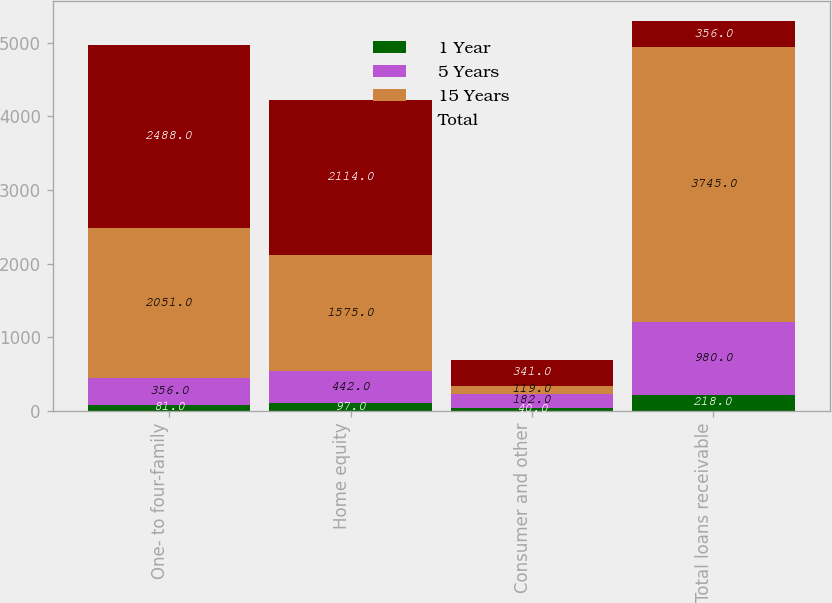<chart> <loc_0><loc_0><loc_500><loc_500><stacked_bar_chart><ecel><fcel>One- to four-family<fcel>Home equity<fcel>Consumer and other<fcel>Total loans receivable<nl><fcel>1 Year<fcel>81<fcel>97<fcel>40<fcel>218<nl><fcel>5 Years<fcel>356<fcel>442<fcel>182<fcel>980<nl><fcel>15 Years<fcel>2051<fcel>1575<fcel>119<fcel>3745<nl><fcel>Total<fcel>2488<fcel>2114<fcel>341<fcel>356<nl></chart> 